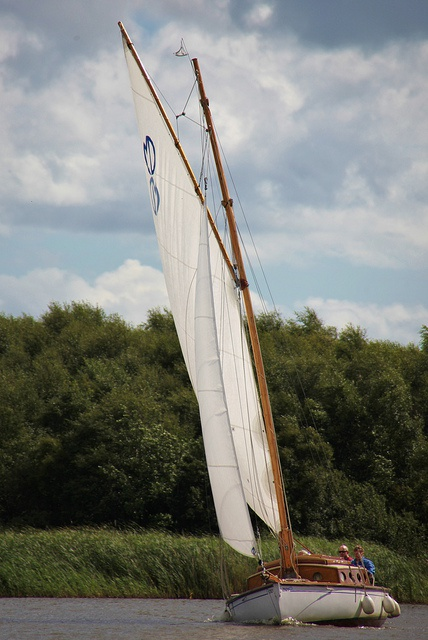Describe the objects in this image and their specific colors. I can see boat in gray, lightgray, and darkgray tones, people in gray, maroon, black, and navy tones, and people in gray, maroon, darkgreen, black, and brown tones in this image. 